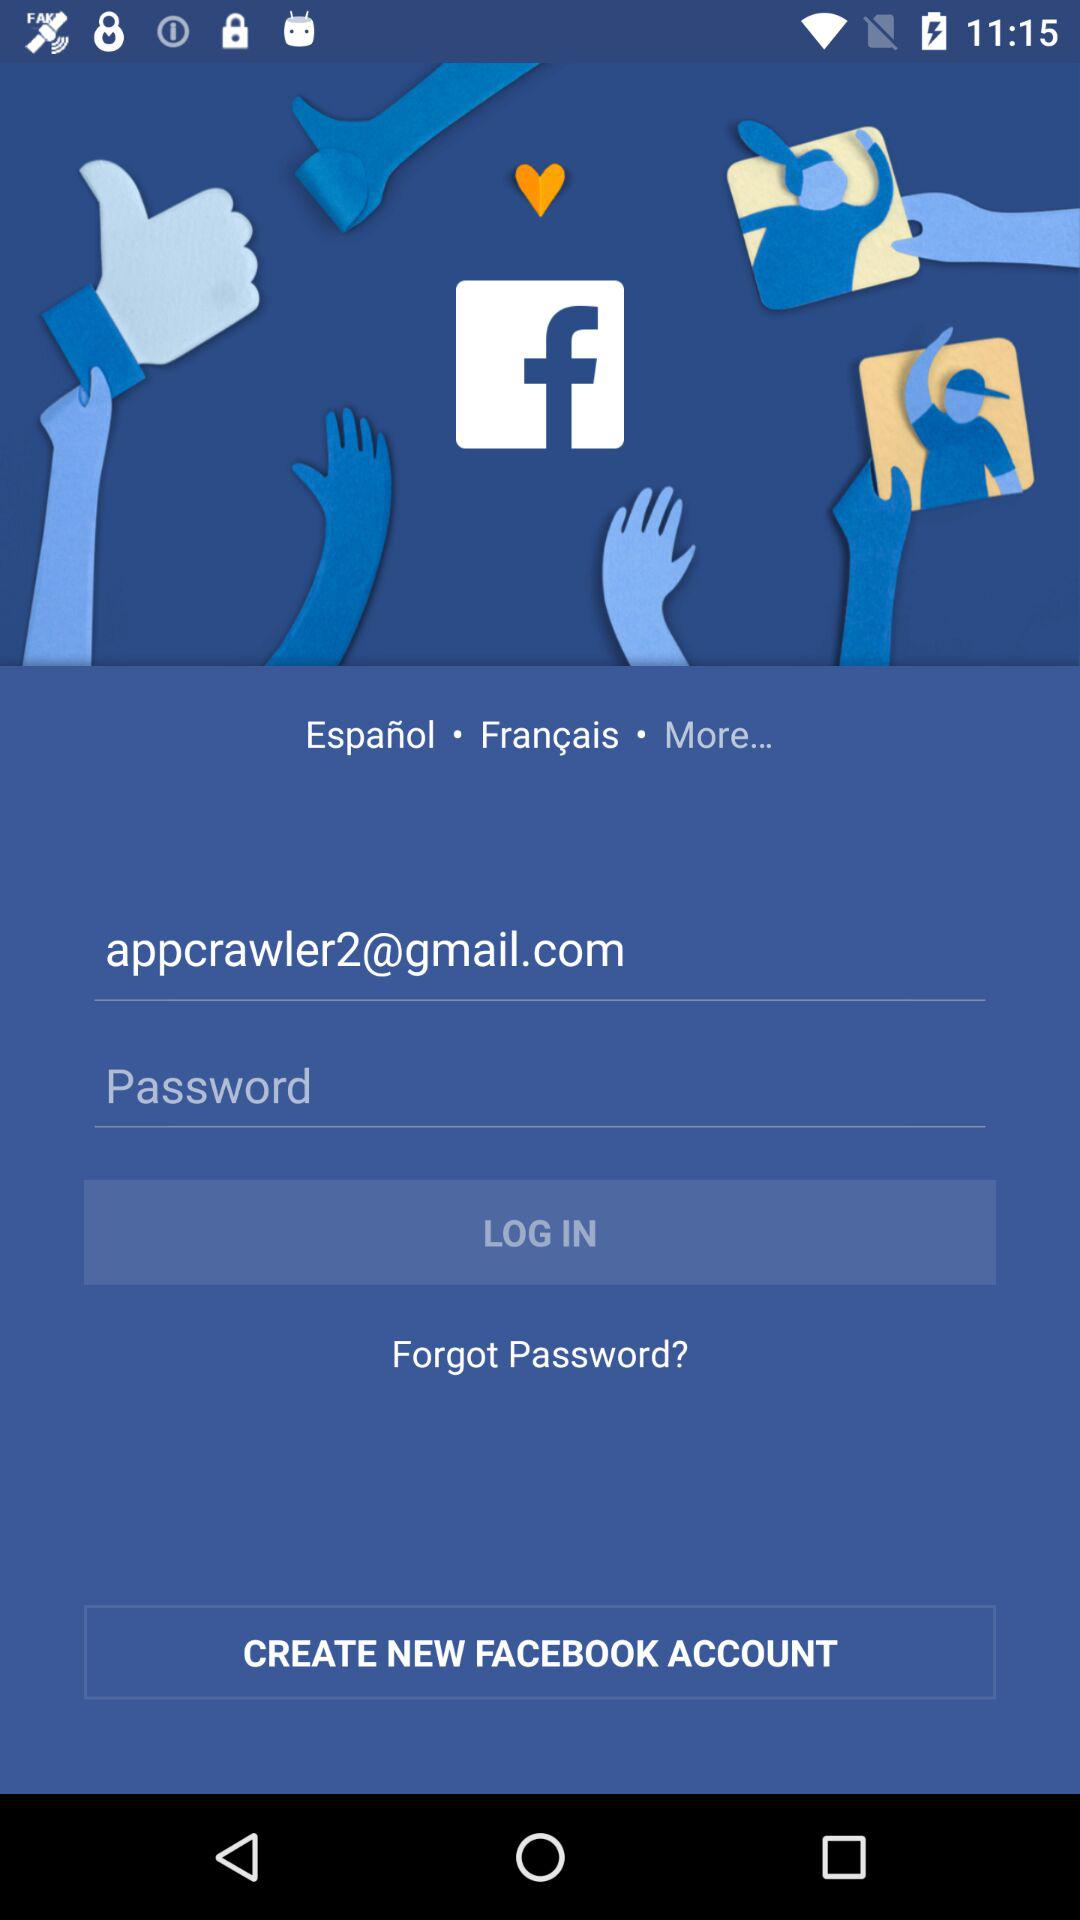What is the email address? The email address is appcrawler2@gmail.com. 